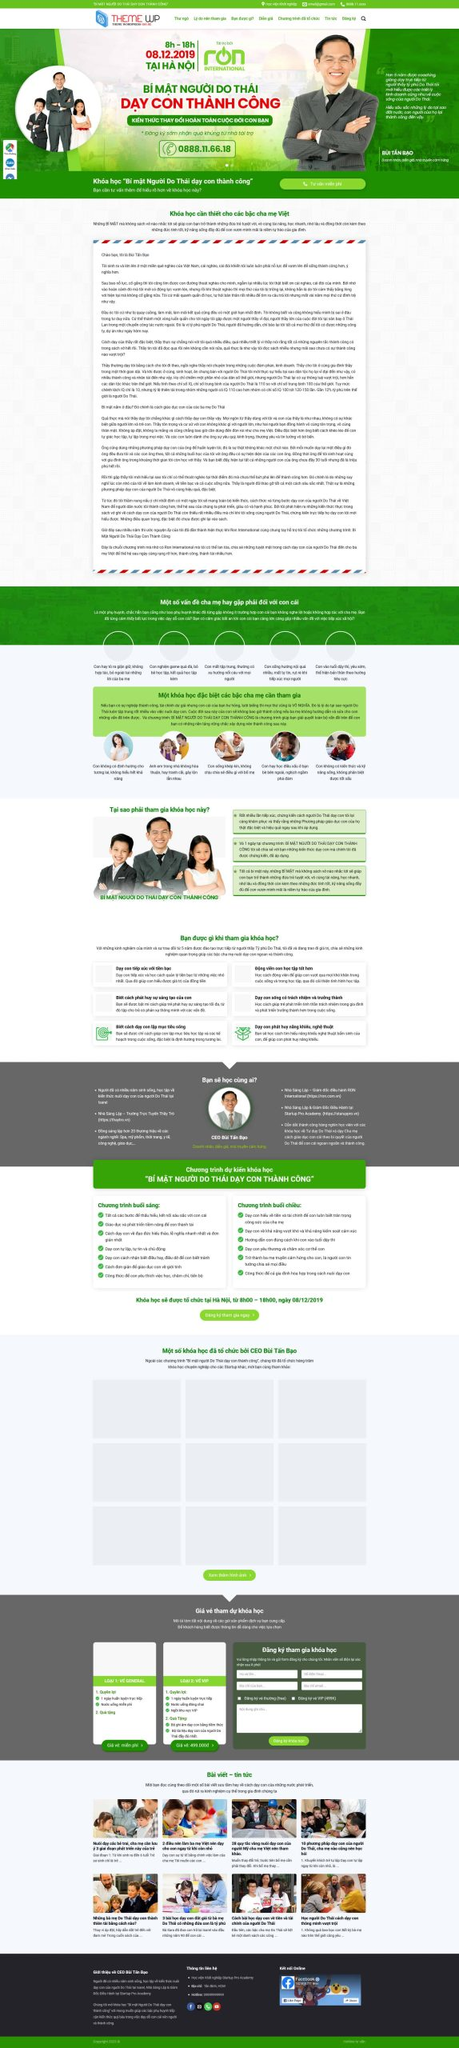Liệt kê 5 ngành nghề, lĩnh vực phù hợp với website này, phân cách các màu sắc bằng dấu phẩy. Chỉ trả về kết quả, phân cách bằng dấy phẩy
 Giáo dục, Tư vấn, Đào tạo, Phát triển cá nhân, Phụ huynh học sinh 